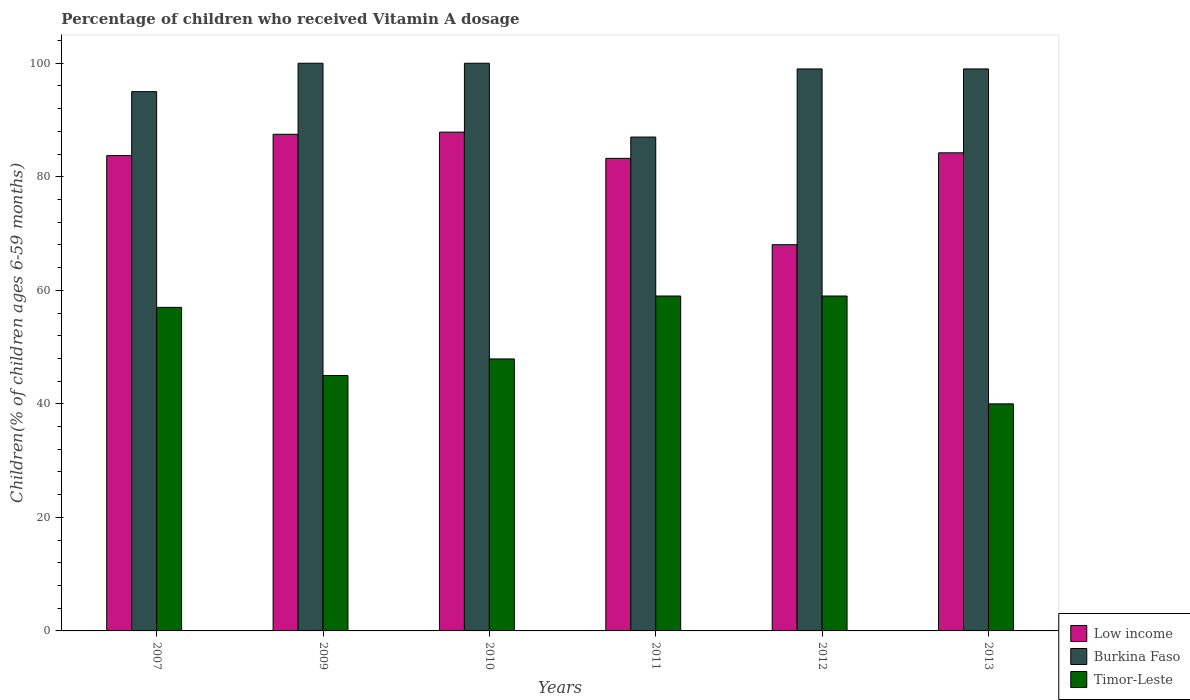How many different coloured bars are there?
Provide a short and direct response. 3. How many groups of bars are there?
Provide a succinct answer. 6. What is the label of the 2nd group of bars from the left?
Provide a succinct answer. 2009. In how many cases, is the number of bars for a given year not equal to the number of legend labels?
Keep it short and to the point. 0. What is the percentage of children who received Vitamin A dosage in Low income in 2012?
Provide a succinct answer. 68.04. Across all years, what is the maximum percentage of children who received Vitamin A dosage in Burkina Faso?
Your answer should be compact. 100. Across all years, what is the minimum percentage of children who received Vitamin A dosage in Low income?
Give a very brief answer. 68.04. In which year was the percentage of children who received Vitamin A dosage in Burkina Faso minimum?
Make the answer very short. 2011. What is the total percentage of children who received Vitamin A dosage in Burkina Faso in the graph?
Provide a short and direct response. 580. What is the difference between the percentage of children who received Vitamin A dosage in Burkina Faso in 2011 and the percentage of children who received Vitamin A dosage in Low income in 2010?
Offer a terse response. -0.87. What is the average percentage of children who received Vitamin A dosage in Timor-Leste per year?
Give a very brief answer. 51.32. In the year 2007, what is the difference between the percentage of children who received Vitamin A dosage in Timor-Leste and percentage of children who received Vitamin A dosage in Low income?
Give a very brief answer. -26.73. In how many years, is the percentage of children who received Vitamin A dosage in Timor-Leste greater than 28 %?
Your answer should be compact. 6. Is the percentage of children who received Vitamin A dosage in Low income in 2011 less than that in 2012?
Offer a terse response. No. What is the difference between the highest and the lowest percentage of children who received Vitamin A dosage in Low income?
Offer a very short reply. 19.83. In how many years, is the percentage of children who received Vitamin A dosage in Burkina Faso greater than the average percentage of children who received Vitamin A dosage in Burkina Faso taken over all years?
Your response must be concise. 4. What does the 2nd bar from the left in 2011 represents?
Provide a short and direct response. Burkina Faso. What does the 1st bar from the right in 2010 represents?
Your answer should be compact. Timor-Leste. Is it the case that in every year, the sum of the percentage of children who received Vitamin A dosage in Burkina Faso and percentage of children who received Vitamin A dosage in Low income is greater than the percentage of children who received Vitamin A dosage in Timor-Leste?
Keep it short and to the point. Yes. How many bars are there?
Ensure brevity in your answer.  18. What is the difference between two consecutive major ticks on the Y-axis?
Offer a terse response. 20. Are the values on the major ticks of Y-axis written in scientific E-notation?
Offer a terse response. No. Does the graph contain any zero values?
Provide a short and direct response. No. Does the graph contain grids?
Provide a succinct answer. No. Where does the legend appear in the graph?
Provide a succinct answer. Bottom right. How many legend labels are there?
Offer a very short reply. 3. How are the legend labels stacked?
Provide a short and direct response. Vertical. What is the title of the graph?
Provide a succinct answer. Percentage of children who received Vitamin A dosage. Does "Angola" appear as one of the legend labels in the graph?
Ensure brevity in your answer.  No. What is the label or title of the Y-axis?
Offer a very short reply. Children(% of children ages 6-59 months). What is the Children(% of children ages 6-59 months) of Low income in 2007?
Offer a terse response. 83.73. What is the Children(% of children ages 6-59 months) in Timor-Leste in 2007?
Make the answer very short. 57. What is the Children(% of children ages 6-59 months) in Low income in 2009?
Provide a succinct answer. 87.49. What is the Children(% of children ages 6-59 months) in Low income in 2010?
Make the answer very short. 87.87. What is the Children(% of children ages 6-59 months) in Burkina Faso in 2010?
Keep it short and to the point. 100. What is the Children(% of children ages 6-59 months) in Timor-Leste in 2010?
Your answer should be compact. 47.91. What is the Children(% of children ages 6-59 months) in Low income in 2011?
Provide a succinct answer. 83.25. What is the Children(% of children ages 6-59 months) of Timor-Leste in 2011?
Your answer should be compact. 59. What is the Children(% of children ages 6-59 months) of Low income in 2012?
Your answer should be compact. 68.04. What is the Children(% of children ages 6-59 months) in Low income in 2013?
Ensure brevity in your answer.  84.22. Across all years, what is the maximum Children(% of children ages 6-59 months) of Low income?
Your response must be concise. 87.87. Across all years, what is the minimum Children(% of children ages 6-59 months) of Low income?
Your answer should be very brief. 68.04. Across all years, what is the minimum Children(% of children ages 6-59 months) of Burkina Faso?
Offer a very short reply. 87. What is the total Children(% of children ages 6-59 months) in Low income in the graph?
Provide a succinct answer. 494.6. What is the total Children(% of children ages 6-59 months) in Burkina Faso in the graph?
Your response must be concise. 580. What is the total Children(% of children ages 6-59 months) of Timor-Leste in the graph?
Provide a short and direct response. 307.91. What is the difference between the Children(% of children ages 6-59 months) in Low income in 2007 and that in 2009?
Keep it short and to the point. -3.75. What is the difference between the Children(% of children ages 6-59 months) in Burkina Faso in 2007 and that in 2009?
Give a very brief answer. -5. What is the difference between the Children(% of children ages 6-59 months) in Timor-Leste in 2007 and that in 2009?
Offer a terse response. 12. What is the difference between the Children(% of children ages 6-59 months) of Low income in 2007 and that in 2010?
Make the answer very short. -4.13. What is the difference between the Children(% of children ages 6-59 months) of Burkina Faso in 2007 and that in 2010?
Provide a short and direct response. -5. What is the difference between the Children(% of children ages 6-59 months) in Timor-Leste in 2007 and that in 2010?
Provide a succinct answer. 9.09. What is the difference between the Children(% of children ages 6-59 months) in Low income in 2007 and that in 2011?
Give a very brief answer. 0.48. What is the difference between the Children(% of children ages 6-59 months) in Timor-Leste in 2007 and that in 2011?
Keep it short and to the point. -2. What is the difference between the Children(% of children ages 6-59 months) in Low income in 2007 and that in 2012?
Give a very brief answer. 15.69. What is the difference between the Children(% of children ages 6-59 months) of Burkina Faso in 2007 and that in 2012?
Your answer should be very brief. -4. What is the difference between the Children(% of children ages 6-59 months) in Timor-Leste in 2007 and that in 2012?
Your response must be concise. -2. What is the difference between the Children(% of children ages 6-59 months) of Low income in 2007 and that in 2013?
Make the answer very short. -0.49. What is the difference between the Children(% of children ages 6-59 months) in Burkina Faso in 2007 and that in 2013?
Keep it short and to the point. -4. What is the difference between the Children(% of children ages 6-59 months) of Low income in 2009 and that in 2010?
Make the answer very short. -0.38. What is the difference between the Children(% of children ages 6-59 months) of Burkina Faso in 2009 and that in 2010?
Make the answer very short. 0. What is the difference between the Children(% of children ages 6-59 months) in Timor-Leste in 2009 and that in 2010?
Offer a terse response. -2.91. What is the difference between the Children(% of children ages 6-59 months) in Low income in 2009 and that in 2011?
Ensure brevity in your answer.  4.24. What is the difference between the Children(% of children ages 6-59 months) in Timor-Leste in 2009 and that in 2011?
Your answer should be very brief. -14. What is the difference between the Children(% of children ages 6-59 months) of Low income in 2009 and that in 2012?
Your answer should be very brief. 19.45. What is the difference between the Children(% of children ages 6-59 months) in Burkina Faso in 2009 and that in 2012?
Your answer should be compact. 1. What is the difference between the Children(% of children ages 6-59 months) of Low income in 2009 and that in 2013?
Ensure brevity in your answer.  3.26. What is the difference between the Children(% of children ages 6-59 months) in Burkina Faso in 2009 and that in 2013?
Offer a very short reply. 1. What is the difference between the Children(% of children ages 6-59 months) of Low income in 2010 and that in 2011?
Provide a short and direct response. 4.62. What is the difference between the Children(% of children ages 6-59 months) of Timor-Leste in 2010 and that in 2011?
Make the answer very short. -11.09. What is the difference between the Children(% of children ages 6-59 months) of Low income in 2010 and that in 2012?
Make the answer very short. 19.83. What is the difference between the Children(% of children ages 6-59 months) of Burkina Faso in 2010 and that in 2012?
Offer a very short reply. 1. What is the difference between the Children(% of children ages 6-59 months) in Timor-Leste in 2010 and that in 2012?
Your response must be concise. -11.09. What is the difference between the Children(% of children ages 6-59 months) in Low income in 2010 and that in 2013?
Give a very brief answer. 3.64. What is the difference between the Children(% of children ages 6-59 months) of Timor-Leste in 2010 and that in 2013?
Keep it short and to the point. 7.91. What is the difference between the Children(% of children ages 6-59 months) in Low income in 2011 and that in 2012?
Your answer should be very brief. 15.21. What is the difference between the Children(% of children ages 6-59 months) in Burkina Faso in 2011 and that in 2012?
Give a very brief answer. -12. What is the difference between the Children(% of children ages 6-59 months) of Low income in 2011 and that in 2013?
Your response must be concise. -0.97. What is the difference between the Children(% of children ages 6-59 months) of Burkina Faso in 2011 and that in 2013?
Your response must be concise. -12. What is the difference between the Children(% of children ages 6-59 months) in Timor-Leste in 2011 and that in 2013?
Give a very brief answer. 19. What is the difference between the Children(% of children ages 6-59 months) in Low income in 2012 and that in 2013?
Your answer should be very brief. -16.18. What is the difference between the Children(% of children ages 6-59 months) in Low income in 2007 and the Children(% of children ages 6-59 months) in Burkina Faso in 2009?
Offer a very short reply. -16.27. What is the difference between the Children(% of children ages 6-59 months) in Low income in 2007 and the Children(% of children ages 6-59 months) in Timor-Leste in 2009?
Offer a very short reply. 38.73. What is the difference between the Children(% of children ages 6-59 months) in Low income in 2007 and the Children(% of children ages 6-59 months) in Burkina Faso in 2010?
Your response must be concise. -16.27. What is the difference between the Children(% of children ages 6-59 months) of Low income in 2007 and the Children(% of children ages 6-59 months) of Timor-Leste in 2010?
Keep it short and to the point. 35.82. What is the difference between the Children(% of children ages 6-59 months) of Burkina Faso in 2007 and the Children(% of children ages 6-59 months) of Timor-Leste in 2010?
Provide a succinct answer. 47.09. What is the difference between the Children(% of children ages 6-59 months) of Low income in 2007 and the Children(% of children ages 6-59 months) of Burkina Faso in 2011?
Provide a short and direct response. -3.27. What is the difference between the Children(% of children ages 6-59 months) of Low income in 2007 and the Children(% of children ages 6-59 months) of Timor-Leste in 2011?
Your response must be concise. 24.73. What is the difference between the Children(% of children ages 6-59 months) of Burkina Faso in 2007 and the Children(% of children ages 6-59 months) of Timor-Leste in 2011?
Your answer should be very brief. 36. What is the difference between the Children(% of children ages 6-59 months) in Low income in 2007 and the Children(% of children ages 6-59 months) in Burkina Faso in 2012?
Provide a short and direct response. -15.27. What is the difference between the Children(% of children ages 6-59 months) of Low income in 2007 and the Children(% of children ages 6-59 months) of Timor-Leste in 2012?
Give a very brief answer. 24.73. What is the difference between the Children(% of children ages 6-59 months) in Low income in 2007 and the Children(% of children ages 6-59 months) in Burkina Faso in 2013?
Your response must be concise. -15.27. What is the difference between the Children(% of children ages 6-59 months) of Low income in 2007 and the Children(% of children ages 6-59 months) of Timor-Leste in 2013?
Keep it short and to the point. 43.73. What is the difference between the Children(% of children ages 6-59 months) in Burkina Faso in 2007 and the Children(% of children ages 6-59 months) in Timor-Leste in 2013?
Your answer should be compact. 55. What is the difference between the Children(% of children ages 6-59 months) of Low income in 2009 and the Children(% of children ages 6-59 months) of Burkina Faso in 2010?
Your response must be concise. -12.51. What is the difference between the Children(% of children ages 6-59 months) in Low income in 2009 and the Children(% of children ages 6-59 months) in Timor-Leste in 2010?
Your answer should be very brief. 39.57. What is the difference between the Children(% of children ages 6-59 months) in Burkina Faso in 2009 and the Children(% of children ages 6-59 months) in Timor-Leste in 2010?
Offer a very short reply. 52.09. What is the difference between the Children(% of children ages 6-59 months) in Low income in 2009 and the Children(% of children ages 6-59 months) in Burkina Faso in 2011?
Offer a terse response. 0.49. What is the difference between the Children(% of children ages 6-59 months) in Low income in 2009 and the Children(% of children ages 6-59 months) in Timor-Leste in 2011?
Offer a terse response. 28.49. What is the difference between the Children(% of children ages 6-59 months) in Burkina Faso in 2009 and the Children(% of children ages 6-59 months) in Timor-Leste in 2011?
Ensure brevity in your answer.  41. What is the difference between the Children(% of children ages 6-59 months) of Low income in 2009 and the Children(% of children ages 6-59 months) of Burkina Faso in 2012?
Your response must be concise. -11.51. What is the difference between the Children(% of children ages 6-59 months) in Low income in 2009 and the Children(% of children ages 6-59 months) in Timor-Leste in 2012?
Your answer should be very brief. 28.49. What is the difference between the Children(% of children ages 6-59 months) in Low income in 2009 and the Children(% of children ages 6-59 months) in Burkina Faso in 2013?
Offer a terse response. -11.51. What is the difference between the Children(% of children ages 6-59 months) in Low income in 2009 and the Children(% of children ages 6-59 months) in Timor-Leste in 2013?
Provide a short and direct response. 47.49. What is the difference between the Children(% of children ages 6-59 months) in Burkina Faso in 2009 and the Children(% of children ages 6-59 months) in Timor-Leste in 2013?
Your answer should be very brief. 60. What is the difference between the Children(% of children ages 6-59 months) in Low income in 2010 and the Children(% of children ages 6-59 months) in Burkina Faso in 2011?
Offer a very short reply. 0.87. What is the difference between the Children(% of children ages 6-59 months) in Low income in 2010 and the Children(% of children ages 6-59 months) in Timor-Leste in 2011?
Your answer should be compact. 28.87. What is the difference between the Children(% of children ages 6-59 months) of Burkina Faso in 2010 and the Children(% of children ages 6-59 months) of Timor-Leste in 2011?
Ensure brevity in your answer.  41. What is the difference between the Children(% of children ages 6-59 months) of Low income in 2010 and the Children(% of children ages 6-59 months) of Burkina Faso in 2012?
Provide a short and direct response. -11.13. What is the difference between the Children(% of children ages 6-59 months) in Low income in 2010 and the Children(% of children ages 6-59 months) in Timor-Leste in 2012?
Ensure brevity in your answer.  28.87. What is the difference between the Children(% of children ages 6-59 months) of Low income in 2010 and the Children(% of children ages 6-59 months) of Burkina Faso in 2013?
Provide a succinct answer. -11.13. What is the difference between the Children(% of children ages 6-59 months) of Low income in 2010 and the Children(% of children ages 6-59 months) of Timor-Leste in 2013?
Give a very brief answer. 47.87. What is the difference between the Children(% of children ages 6-59 months) of Burkina Faso in 2010 and the Children(% of children ages 6-59 months) of Timor-Leste in 2013?
Provide a short and direct response. 60. What is the difference between the Children(% of children ages 6-59 months) of Low income in 2011 and the Children(% of children ages 6-59 months) of Burkina Faso in 2012?
Your answer should be compact. -15.75. What is the difference between the Children(% of children ages 6-59 months) of Low income in 2011 and the Children(% of children ages 6-59 months) of Timor-Leste in 2012?
Ensure brevity in your answer.  24.25. What is the difference between the Children(% of children ages 6-59 months) in Burkina Faso in 2011 and the Children(% of children ages 6-59 months) in Timor-Leste in 2012?
Keep it short and to the point. 28. What is the difference between the Children(% of children ages 6-59 months) of Low income in 2011 and the Children(% of children ages 6-59 months) of Burkina Faso in 2013?
Provide a short and direct response. -15.75. What is the difference between the Children(% of children ages 6-59 months) in Low income in 2011 and the Children(% of children ages 6-59 months) in Timor-Leste in 2013?
Your answer should be very brief. 43.25. What is the difference between the Children(% of children ages 6-59 months) of Low income in 2012 and the Children(% of children ages 6-59 months) of Burkina Faso in 2013?
Provide a succinct answer. -30.96. What is the difference between the Children(% of children ages 6-59 months) in Low income in 2012 and the Children(% of children ages 6-59 months) in Timor-Leste in 2013?
Your answer should be very brief. 28.04. What is the difference between the Children(% of children ages 6-59 months) in Burkina Faso in 2012 and the Children(% of children ages 6-59 months) in Timor-Leste in 2013?
Provide a succinct answer. 59. What is the average Children(% of children ages 6-59 months) of Low income per year?
Give a very brief answer. 82.43. What is the average Children(% of children ages 6-59 months) in Burkina Faso per year?
Provide a short and direct response. 96.67. What is the average Children(% of children ages 6-59 months) in Timor-Leste per year?
Provide a succinct answer. 51.32. In the year 2007, what is the difference between the Children(% of children ages 6-59 months) of Low income and Children(% of children ages 6-59 months) of Burkina Faso?
Provide a short and direct response. -11.27. In the year 2007, what is the difference between the Children(% of children ages 6-59 months) in Low income and Children(% of children ages 6-59 months) in Timor-Leste?
Your response must be concise. 26.73. In the year 2009, what is the difference between the Children(% of children ages 6-59 months) in Low income and Children(% of children ages 6-59 months) in Burkina Faso?
Provide a succinct answer. -12.51. In the year 2009, what is the difference between the Children(% of children ages 6-59 months) of Low income and Children(% of children ages 6-59 months) of Timor-Leste?
Make the answer very short. 42.49. In the year 2009, what is the difference between the Children(% of children ages 6-59 months) in Burkina Faso and Children(% of children ages 6-59 months) in Timor-Leste?
Offer a terse response. 55. In the year 2010, what is the difference between the Children(% of children ages 6-59 months) in Low income and Children(% of children ages 6-59 months) in Burkina Faso?
Your response must be concise. -12.13. In the year 2010, what is the difference between the Children(% of children ages 6-59 months) of Low income and Children(% of children ages 6-59 months) of Timor-Leste?
Your answer should be very brief. 39.95. In the year 2010, what is the difference between the Children(% of children ages 6-59 months) in Burkina Faso and Children(% of children ages 6-59 months) in Timor-Leste?
Your answer should be compact. 52.09. In the year 2011, what is the difference between the Children(% of children ages 6-59 months) in Low income and Children(% of children ages 6-59 months) in Burkina Faso?
Your answer should be very brief. -3.75. In the year 2011, what is the difference between the Children(% of children ages 6-59 months) in Low income and Children(% of children ages 6-59 months) in Timor-Leste?
Give a very brief answer. 24.25. In the year 2012, what is the difference between the Children(% of children ages 6-59 months) in Low income and Children(% of children ages 6-59 months) in Burkina Faso?
Give a very brief answer. -30.96. In the year 2012, what is the difference between the Children(% of children ages 6-59 months) in Low income and Children(% of children ages 6-59 months) in Timor-Leste?
Your answer should be very brief. 9.04. In the year 2013, what is the difference between the Children(% of children ages 6-59 months) of Low income and Children(% of children ages 6-59 months) of Burkina Faso?
Provide a succinct answer. -14.78. In the year 2013, what is the difference between the Children(% of children ages 6-59 months) in Low income and Children(% of children ages 6-59 months) in Timor-Leste?
Ensure brevity in your answer.  44.22. In the year 2013, what is the difference between the Children(% of children ages 6-59 months) of Burkina Faso and Children(% of children ages 6-59 months) of Timor-Leste?
Make the answer very short. 59. What is the ratio of the Children(% of children ages 6-59 months) in Low income in 2007 to that in 2009?
Give a very brief answer. 0.96. What is the ratio of the Children(% of children ages 6-59 months) of Burkina Faso in 2007 to that in 2009?
Provide a short and direct response. 0.95. What is the ratio of the Children(% of children ages 6-59 months) in Timor-Leste in 2007 to that in 2009?
Make the answer very short. 1.27. What is the ratio of the Children(% of children ages 6-59 months) in Low income in 2007 to that in 2010?
Provide a short and direct response. 0.95. What is the ratio of the Children(% of children ages 6-59 months) of Burkina Faso in 2007 to that in 2010?
Provide a short and direct response. 0.95. What is the ratio of the Children(% of children ages 6-59 months) in Timor-Leste in 2007 to that in 2010?
Provide a succinct answer. 1.19. What is the ratio of the Children(% of children ages 6-59 months) in Burkina Faso in 2007 to that in 2011?
Make the answer very short. 1.09. What is the ratio of the Children(% of children ages 6-59 months) of Timor-Leste in 2007 to that in 2011?
Your answer should be compact. 0.97. What is the ratio of the Children(% of children ages 6-59 months) of Low income in 2007 to that in 2012?
Provide a succinct answer. 1.23. What is the ratio of the Children(% of children ages 6-59 months) in Burkina Faso in 2007 to that in 2012?
Your answer should be very brief. 0.96. What is the ratio of the Children(% of children ages 6-59 months) of Timor-Leste in 2007 to that in 2012?
Your answer should be compact. 0.97. What is the ratio of the Children(% of children ages 6-59 months) of Low income in 2007 to that in 2013?
Offer a very short reply. 0.99. What is the ratio of the Children(% of children ages 6-59 months) in Burkina Faso in 2007 to that in 2013?
Your answer should be very brief. 0.96. What is the ratio of the Children(% of children ages 6-59 months) of Timor-Leste in 2007 to that in 2013?
Make the answer very short. 1.43. What is the ratio of the Children(% of children ages 6-59 months) in Low income in 2009 to that in 2010?
Your response must be concise. 1. What is the ratio of the Children(% of children ages 6-59 months) of Timor-Leste in 2009 to that in 2010?
Your answer should be very brief. 0.94. What is the ratio of the Children(% of children ages 6-59 months) of Low income in 2009 to that in 2011?
Provide a succinct answer. 1.05. What is the ratio of the Children(% of children ages 6-59 months) in Burkina Faso in 2009 to that in 2011?
Your response must be concise. 1.15. What is the ratio of the Children(% of children ages 6-59 months) in Timor-Leste in 2009 to that in 2011?
Offer a very short reply. 0.76. What is the ratio of the Children(% of children ages 6-59 months) of Low income in 2009 to that in 2012?
Ensure brevity in your answer.  1.29. What is the ratio of the Children(% of children ages 6-59 months) in Timor-Leste in 2009 to that in 2012?
Offer a very short reply. 0.76. What is the ratio of the Children(% of children ages 6-59 months) of Low income in 2009 to that in 2013?
Keep it short and to the point. 1.04. What is the ratio of the Children(% of children ages 6-59 months) of Timor-Leste in 2009 to that in 2013?
Your answer should be very brief. 1.12. What is the ratio of the Children(% of children ages 6-59 months) of Low income in 2010 to that in 2011?
Offer a terse response. 1.06. What is the ratio of the Children(% of children ages 6-59 months) in Burkina Faso in 2010 to that in 2011?
Your answer should be compact. 1.15. What is the ratio of the Children(% of children ages 6-59 months) of Timor-Leste in 2010 to that in 2011?
Give a very brief answer. 0.81. What is the ratio of the Children(% of children ages 6-59 months) in Low income in 2010 to that in 2012?
Provide a short and direct response. 1.29. What is the ratio of the Children(% of children ages 6-59 months) in Burkina Faso in 2010 to that in 2012?
Provide a short and direct response. 1.01. What is the ratio of the Children(% of children ages 6-59 months) of Timor-Leste in 2010 to that in 2012?
Your answer should be compact. 0.81. What is the ratio of the Children(% of children ages 6-59 months) in Low income in 2010 to that in 2013?
Offer a terse response. 1.04. What is the ratio of the Children(% of children ages 6-59 months) of Burkina Faso in 2010 to that in 2013?
Your response must be concise. 1.01. What is the ratio of the Children(% of children ages 6-59 months) in Timor-Leste in 2010 to that in 2013?
Provide a succinct answer. 1.2. What is the ratio of the Children(% of children ages 6-59 months) in Low income in 2011 to that in 2012?
Make the answer very short. 1.22. What is the ratio of the Children(% of children ages 6-59 months) of Burkina Faso in 2011 to that in 2012?
Offer a terse response. 0.88. What is the ratio of the Children(% of children ages 6-59 months) in Low income in 2011 to that in 2013?
Offer a very short reply. 0.99. What is the ratio of the Children(% of children ages 6-59 months) in Burkina Faso in 2011 to that in 2013?
Keep it short and to the point. 0.88. What is the ratio of the Children(% of children ages 6-59 months) in Timor-Leste in 2011 to that in 2013?
Provide a succinct answer. 1.48. What is the ratio of the Children(% of children ages 6-59 months) of Low income in 2012 to that in 2013?
Keep it short and to the point. 0.81. What is the ratio of the Children(% of children ages 6-59 months) in Burkina Faso in 2012 to that in 2013?
Make the answer very short. 1. What is the ratio of the Children(% of children ages 6-59 months) in Timor-Leste in 2012 to that in 2013?
Your answer should be very brief. 1.48. What is the difference between the highest and the second highest Children(% of children ages 6-59 months) of Low income?
Offer a terse response. 0.38. What is the difference between the highest and the second highest Children(% of children ages 6-59 months) of Burkina Faso?
Give a very brief answer. 0. What is the difference between the highest and the second highest Children(% of children ages 6-59 months) of Timor-Leste?
Provide a short and direct response. 0. What is the difference between the highest and the lowest Children(% of children ages 6-59 months) of Low income?
Provide a succinct answer. 19.83. What is the difference between the highest and the lowest Children(% of children ages 6-59 months) in Burkina Faso?
Make the answer very short. 13. 